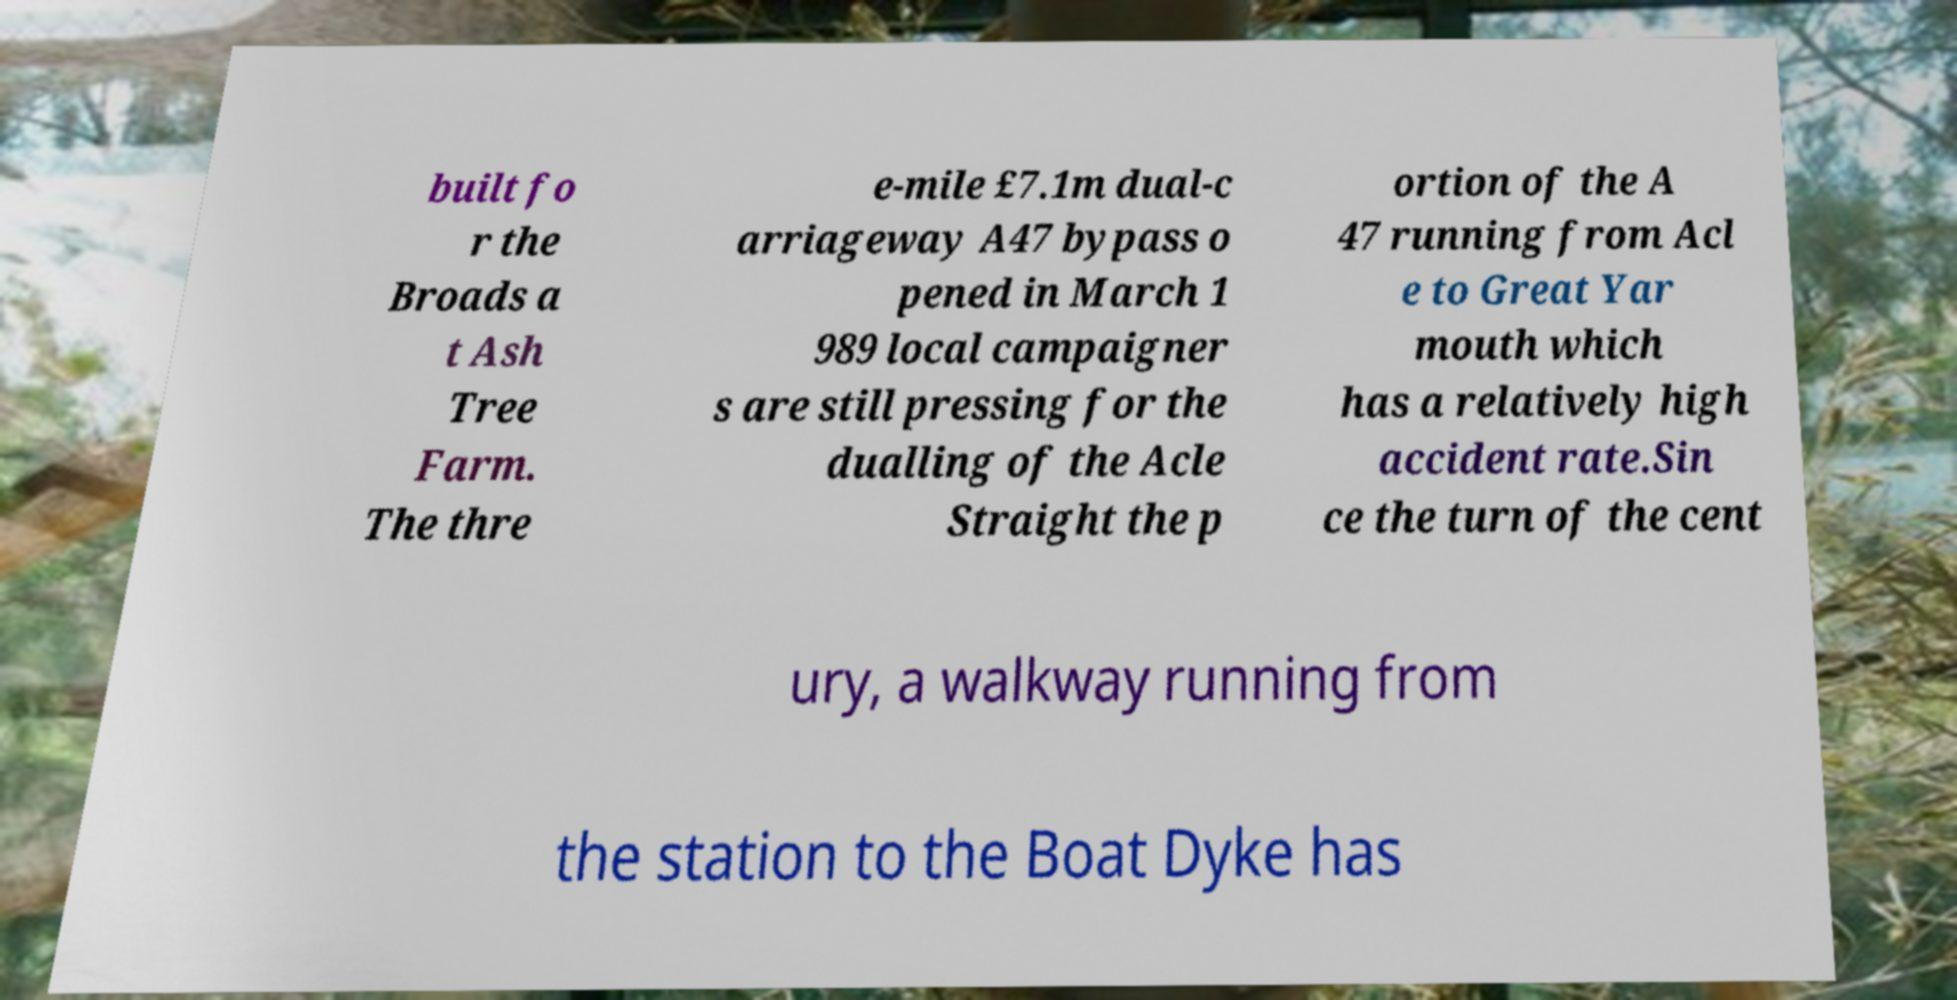Can you accurately transcribe the text from the provided image for me? built fo r the Broads a t Ash Tree Farm. The thre e-mile £7.1m dual-c arriageway A47 bypass o pened in March 1 989 local campaigner s are still pressing for the dualling of the Acle Straight the p ortion of the A 47 running from Acl e to Great Yar mouth which has a relatively high accident rate.Sin ce the turn of the cent ury, a walkway running from the station to the Boat Dyke has 